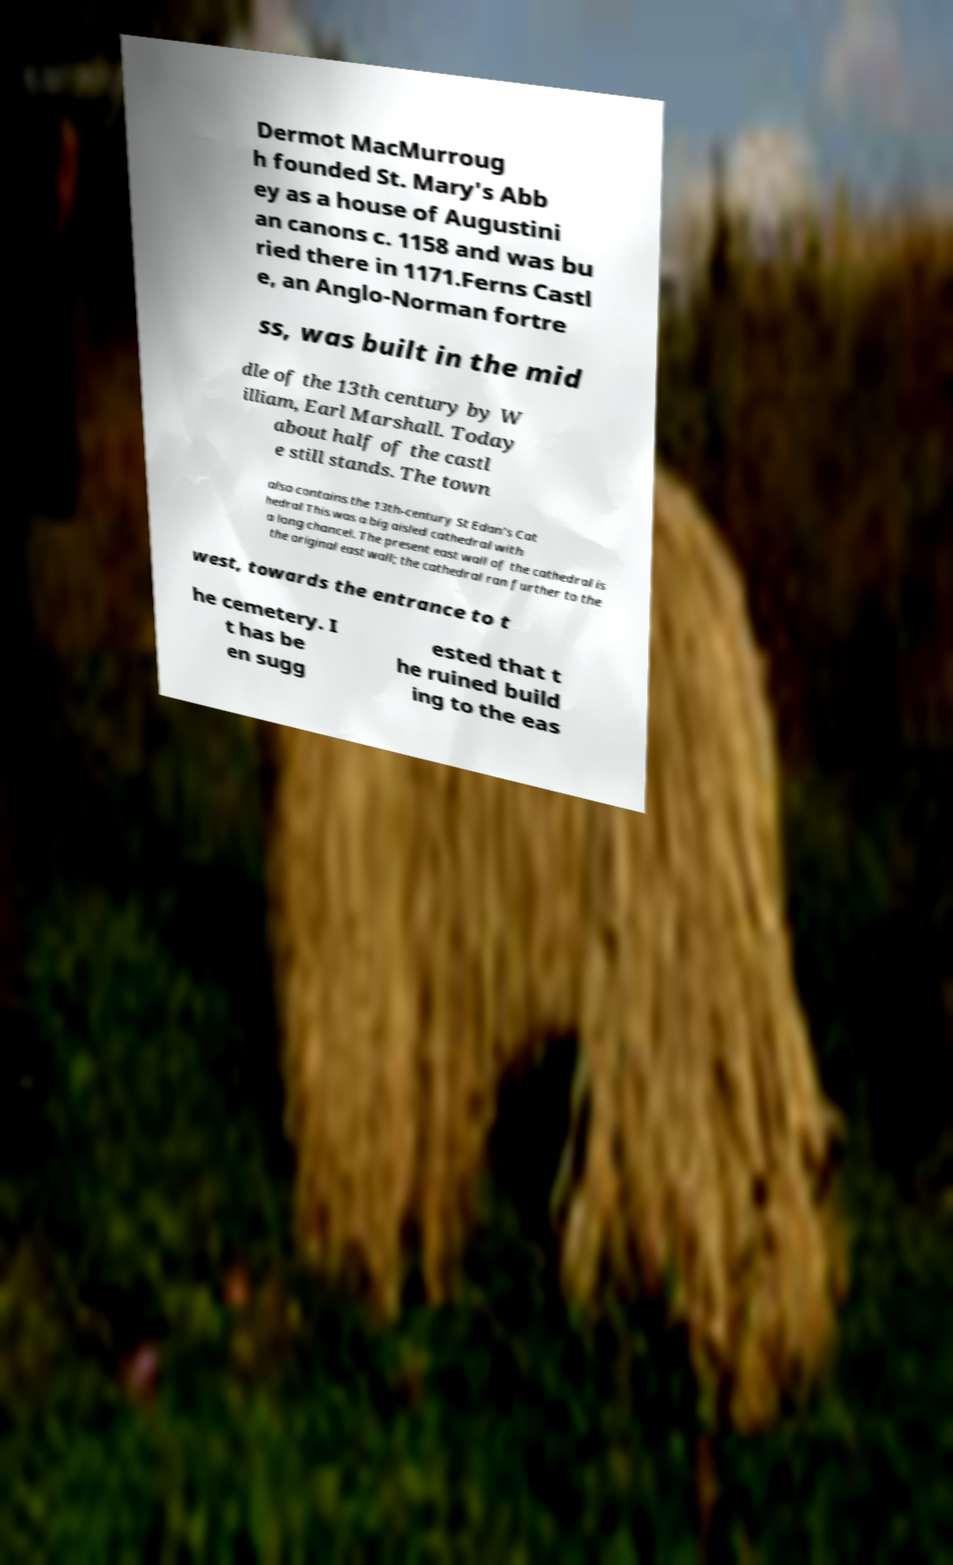Could you assist in decoding the text presented in this image and type it out clearly? Dermot MacMurroug h founded St. Mary's Abb ey as a house of Augustini an canons c. 1158 and was bu ried there in 1171.Ferns Castl e, an Anglo-Norman fortre ss, was built in the mid dle of the 13th century by W illiam, Earl Marshall. Today about half of the castl e still stands. The town also contains the 13th-century St Edan's Cat hedral This was a big aisled cathedral with a long chancel. The present east wall of the cathedral is the original east wall; the cathedral ran further to the west, towards the entrance to t he cemetery. I t has be en sugg ested that t he ruined build ing to the eas 